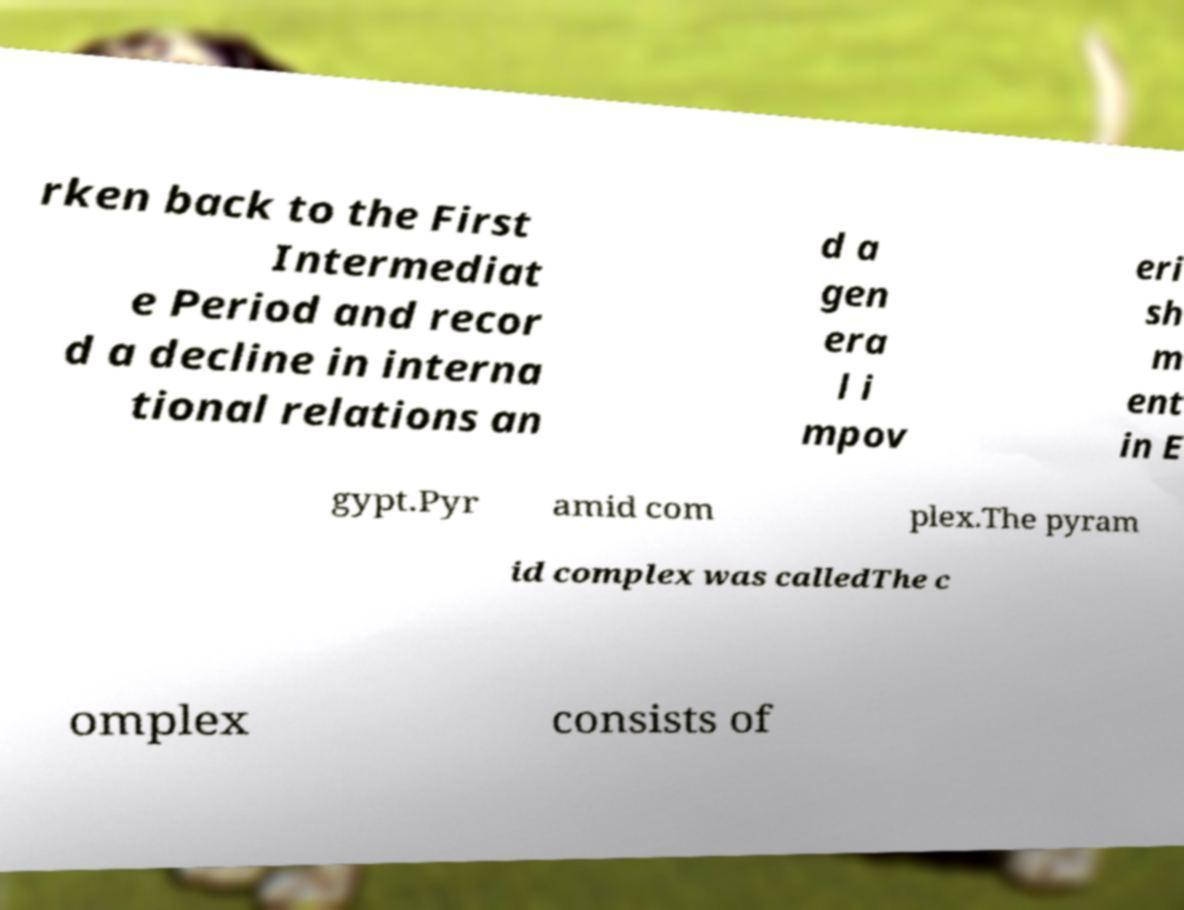Please identify and transcribe the text found in this image. rken back to the First Intermediat e Period and recor d a decline in interna tional relations an d a gen era l i mpov eri sh m ent in E gypt.Pyr amid com plex.The pyram id complex was calledThe c omplex consists of 